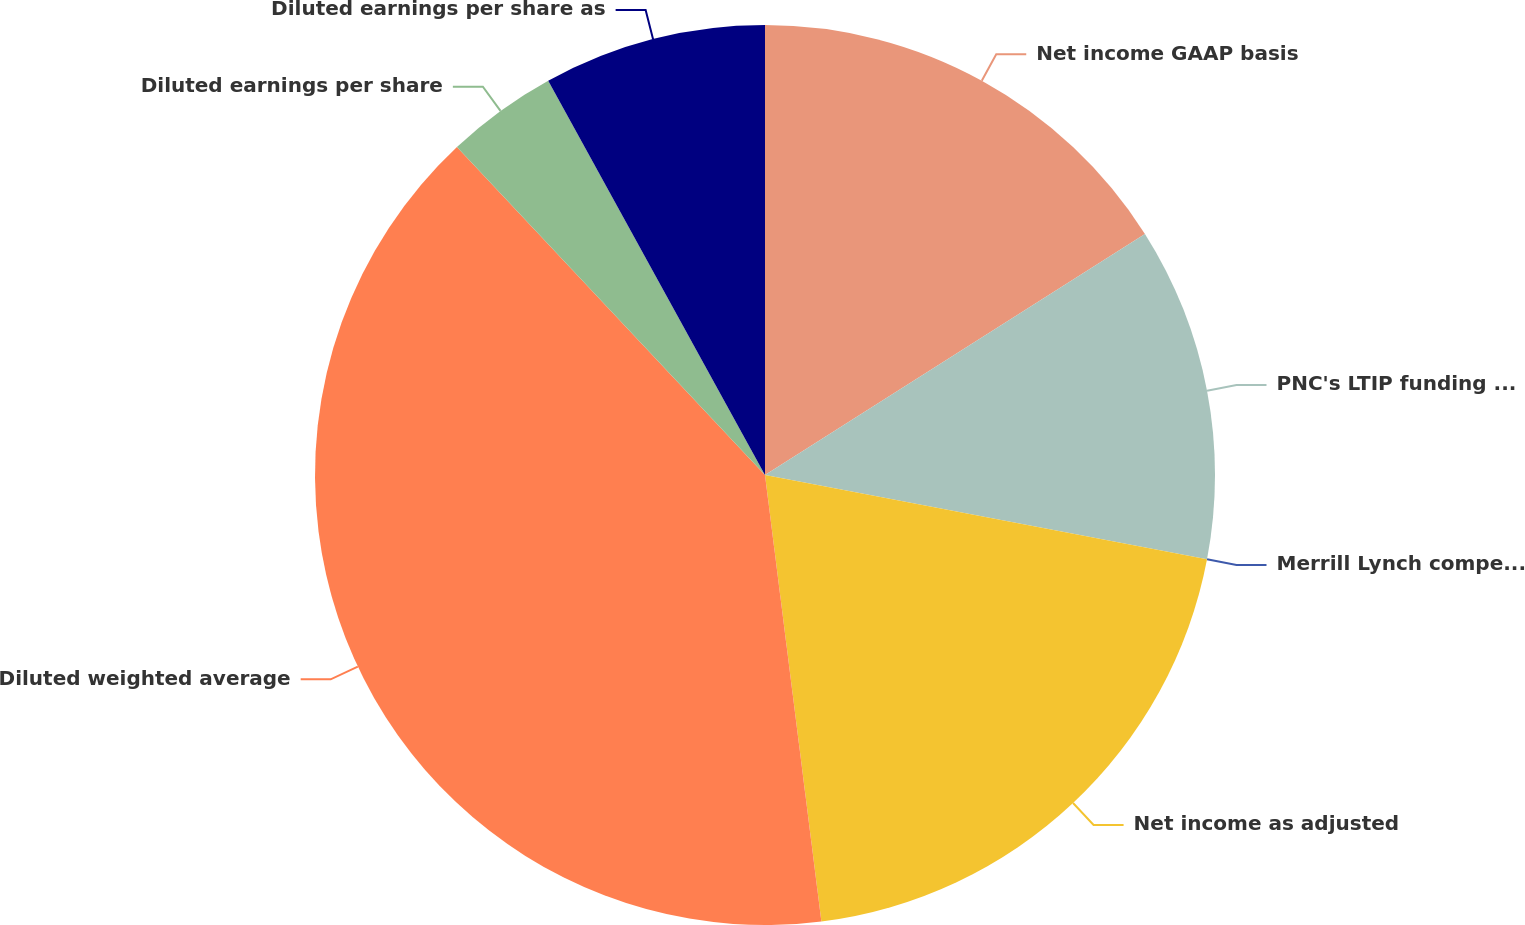Convert chart to OTSL. <chart><loc_0><loc_0><loc_500><loc_500><pie_chart><fcel>Net income GAAP basis<fcel>PNC's LTIP funding obligation<fcel>Merrill Lynch compensation<fcel>Net income as adjusted<fcel>Diluted weighted average<fcel>Diluted earnings per share<fcel>Diluted earnings per share as<nl><fcel>16.0%<fcel>12.0%<fcel>0.0%<fcel>20.0%<fcel>40.0%<fcel>4.0%<fcel>8.0%<nl></chart> 